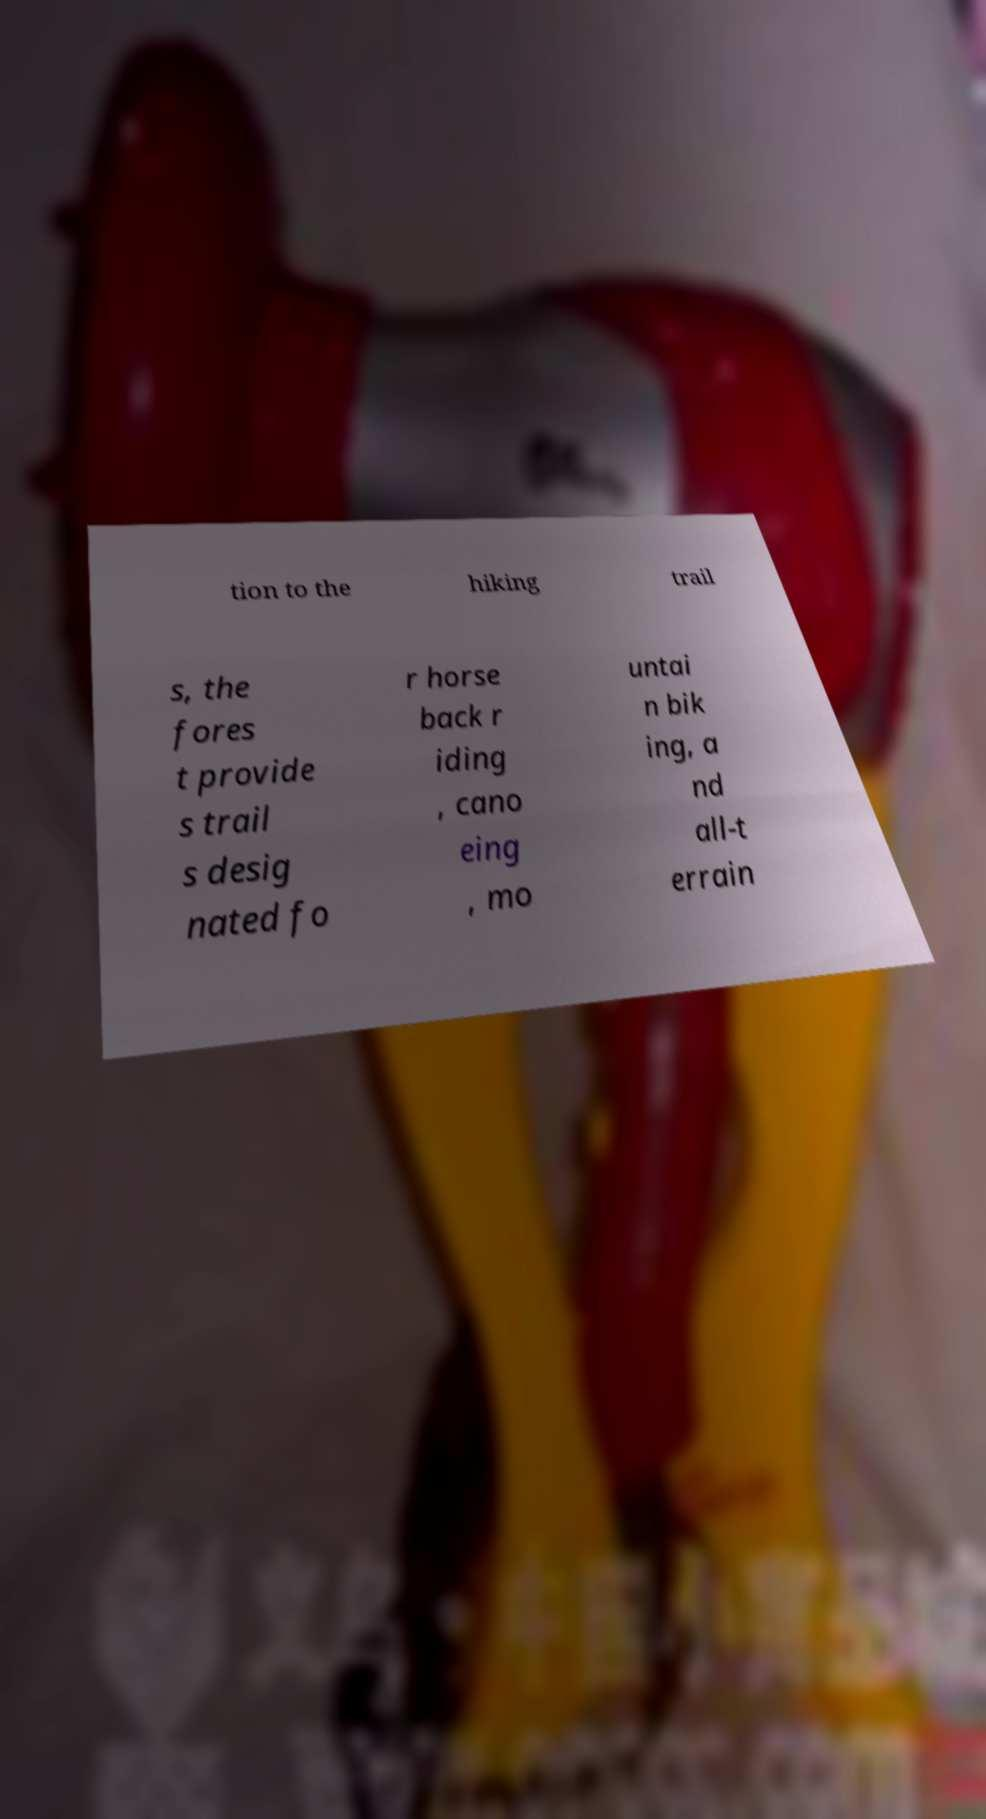I need the written content from this picture converted into text. Can you do that? tion to the hiking trail s, the fores t provide s trail s desig nated fo r horse back r iding , cano eing , mo untai n bik ing, a nd all-t errain 